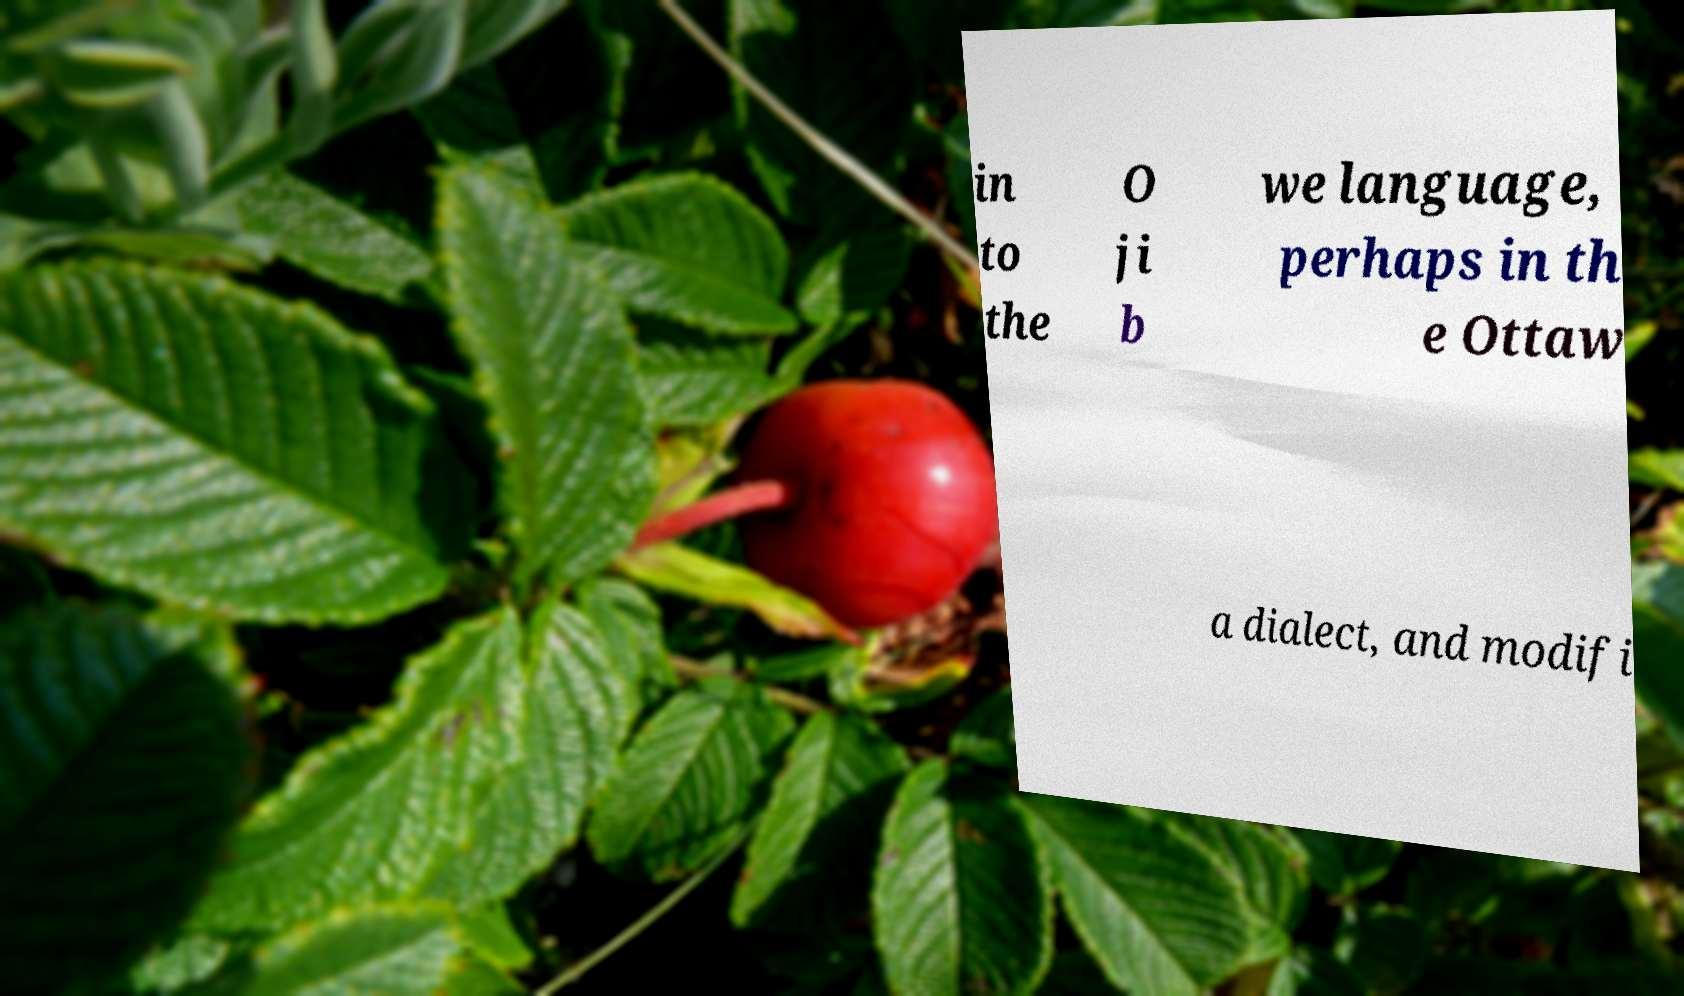Could you assist in decoding the text presented in this image and type it out clearly? in to the O ji b we language, perhaps in th e Ottaw a dialect, and modifi 